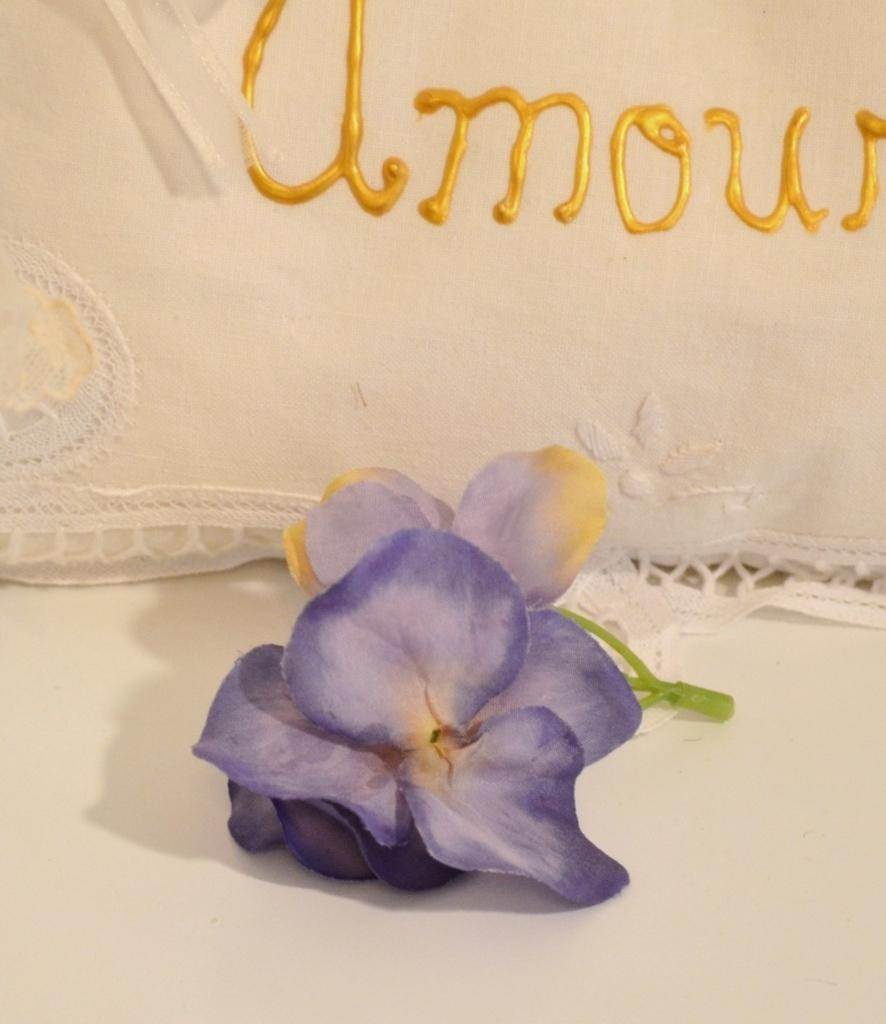What is the color of the flower on the white surface? The flower is violet in color. What is the color of the surface behind the flower? The surface behind the flower is white. What is written on the cloth behind the flower? The cloth has a yellow color name on it. Can you see a monkey pointing at the heart of the flower in the image? No, there is no monkey or heart present in the image. 